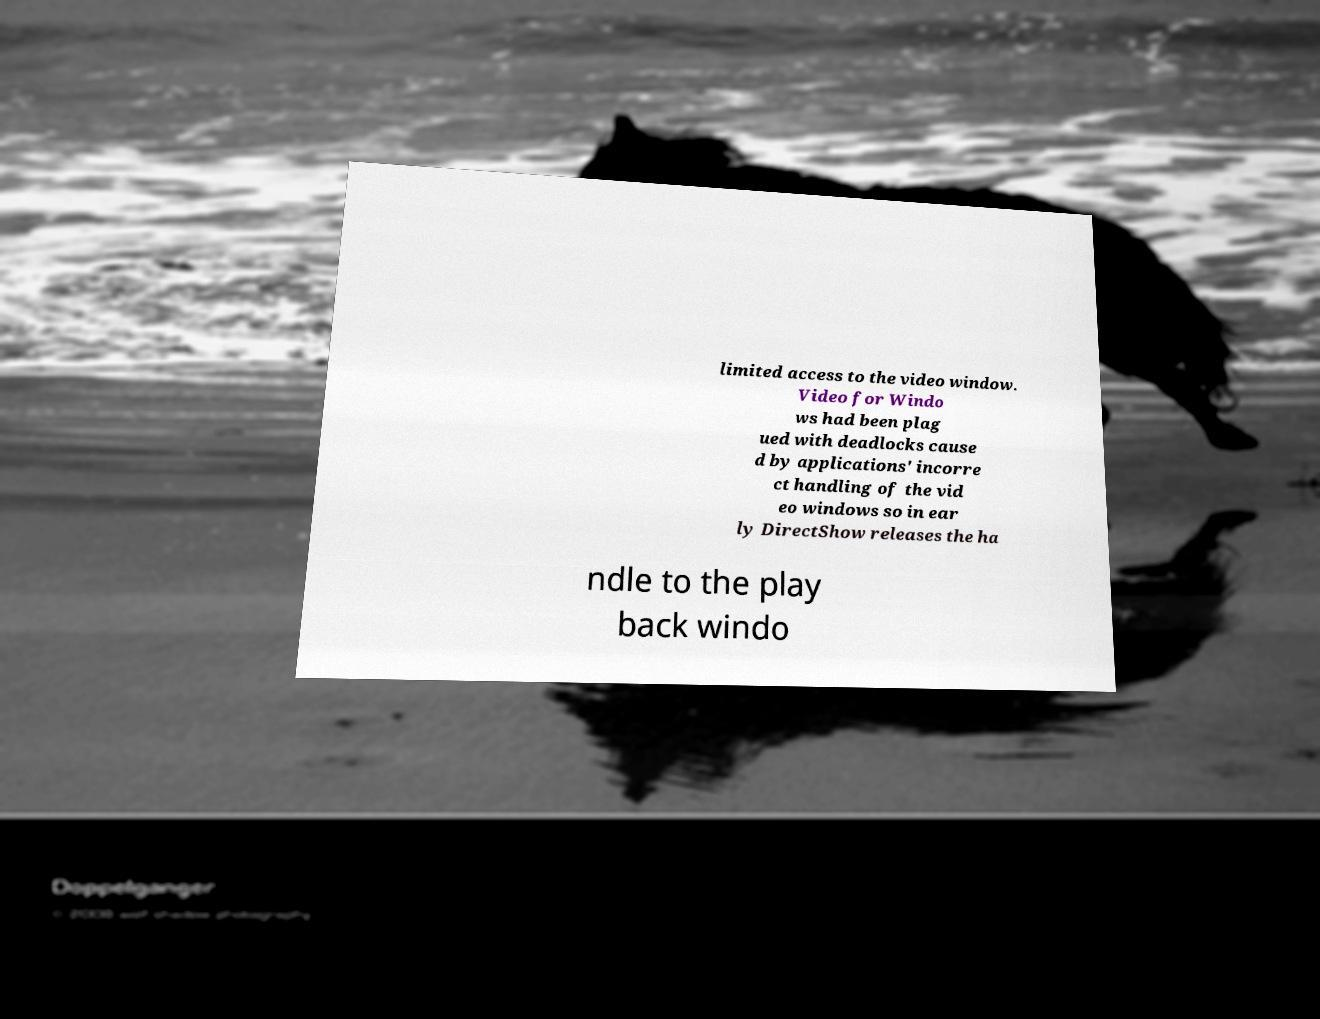I need the written content from this picture converted into text. Can you do that? limited access to the video window. Video for Windo ws had been plag ued with deadlocks cause d by applications' incorre ct handling of the vid eo windows so in ear ly DirectShow releases the ha ndle to the play back windo 